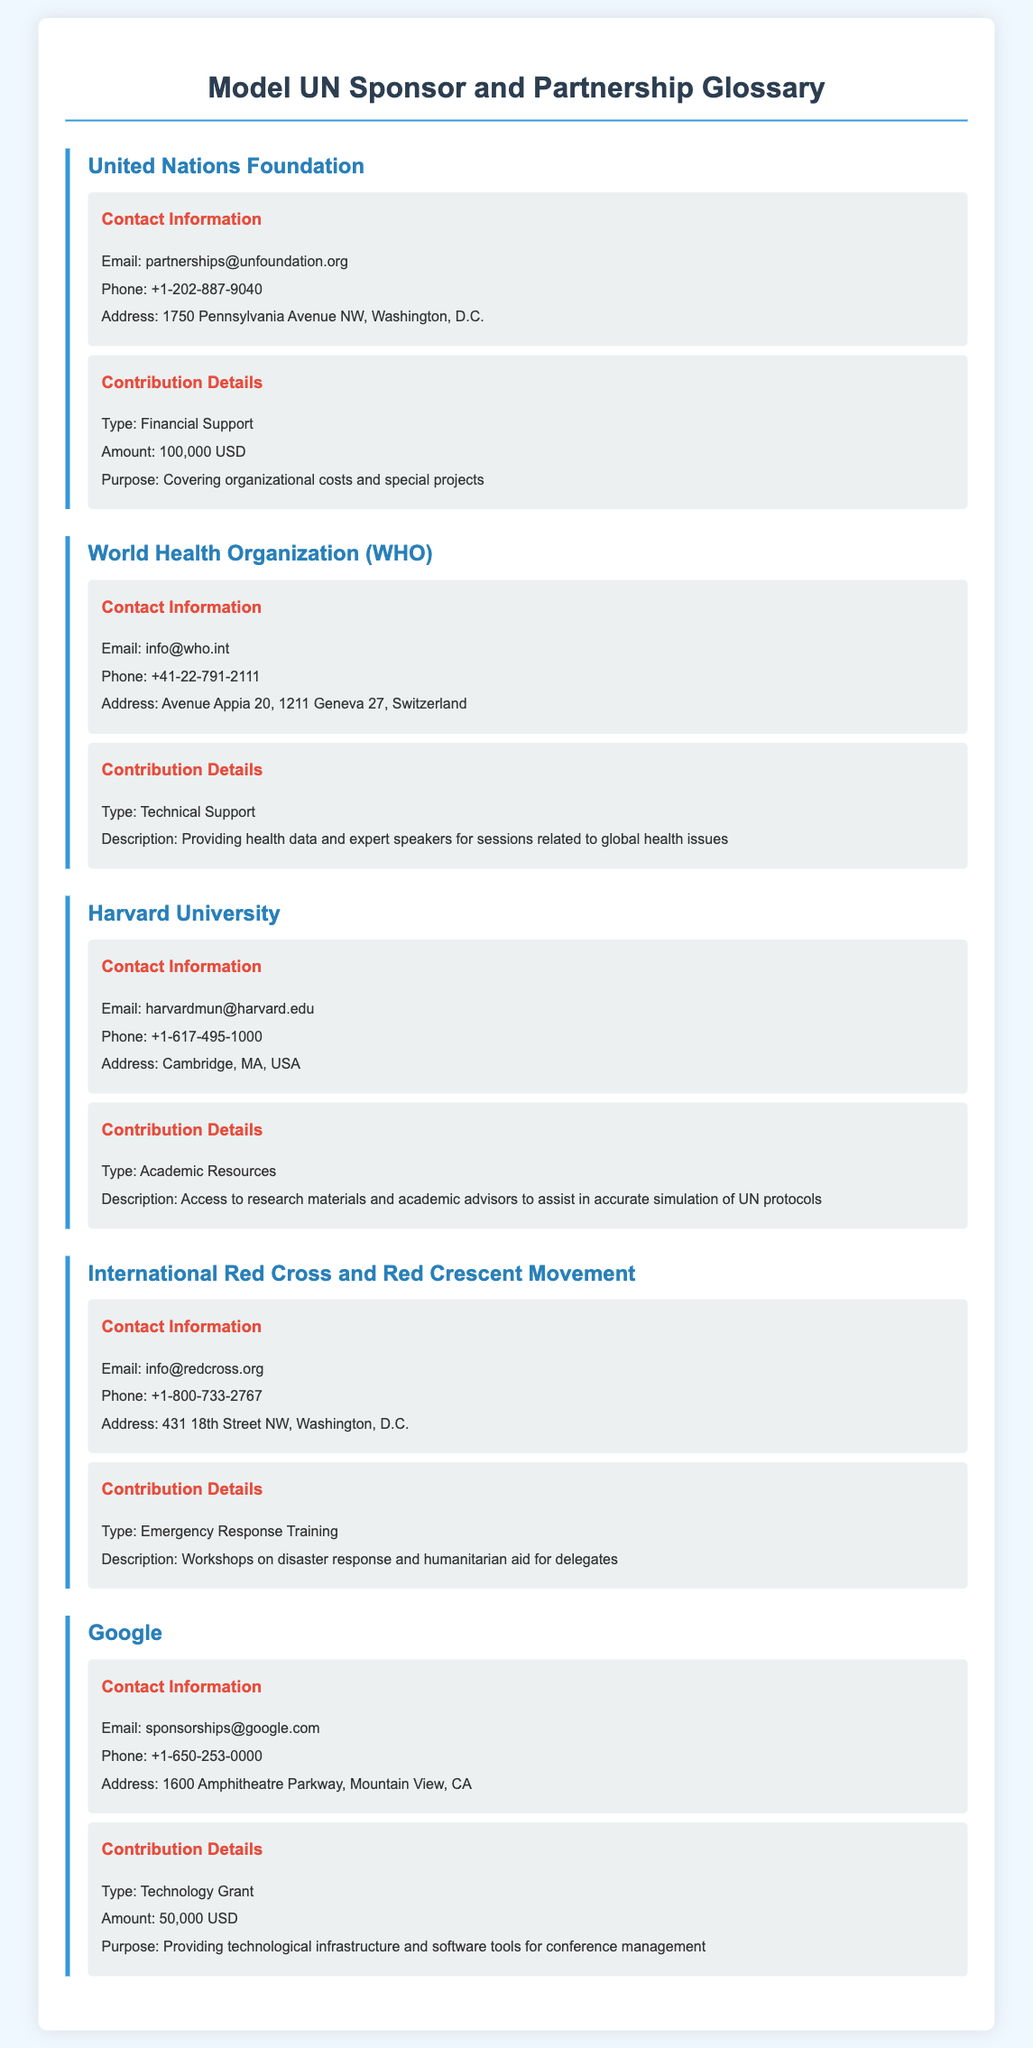what is the email of the United Nations Foundation? The email can be found in the contact information section for the United Nations Foundation.
Answer: partnerships@unfoundation.org how much financial support does the United Nations Foundation provide? The amount of financial support is detailed in the contribution details section for the United Nations Foundation.
Answer: 100,000 USD what is the address of the World Health Organization? The address is listed in the contact information for the World Health Organization.
Answer: Avenue Appia 20, 1211 Geneva 27, Switzerland what type of contribution does Harvard University provide? The type of contribution is specified in the contribution details for Harvard University.
Answer: Academic Resources which organization provides emergency response training? This detail can be found in the contribution details for the International Red Cross and Red Crescent Movement.
Answer: International Red Cross and Red Crescent Movement how much is the technology grant provided by Google? The amount for the technology grant is specified in the contribution details section for Google.
Answer: 50,000 USD who provides health data and expert speakers? The organization that provides these resources is mentioned in the contribution details for the World Health Organization.
Answer: World Health Organization what is the phone number of the International Red Cross and Red Crescent Movement? The phone number can be found in the contact information for the International Red Cross and Red Crescent Movement.
Answer: +1-800-733-2767 